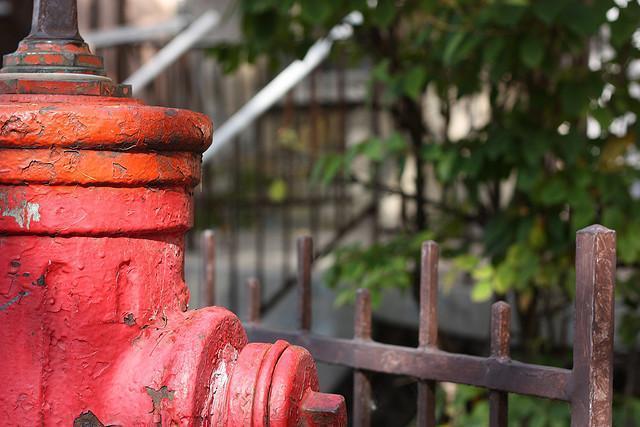How many people are standing in front of the horse?
Give a very brief answer. 0. 